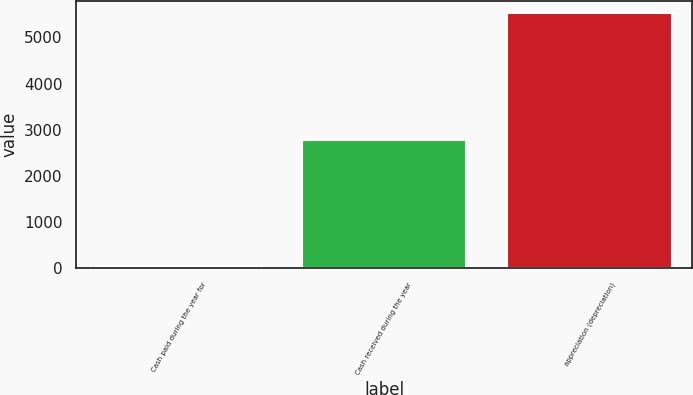Convert chart. <chart><loc_0><loc_0><loc_500><loc_500><bar_chart><fcel>Cash paid during the year for<fcel>Cash received during the year<fcel>appreciation (depreciation)<nl><fcel>38<fcel>2780.9<fcel>5523.8<nl></chart> 